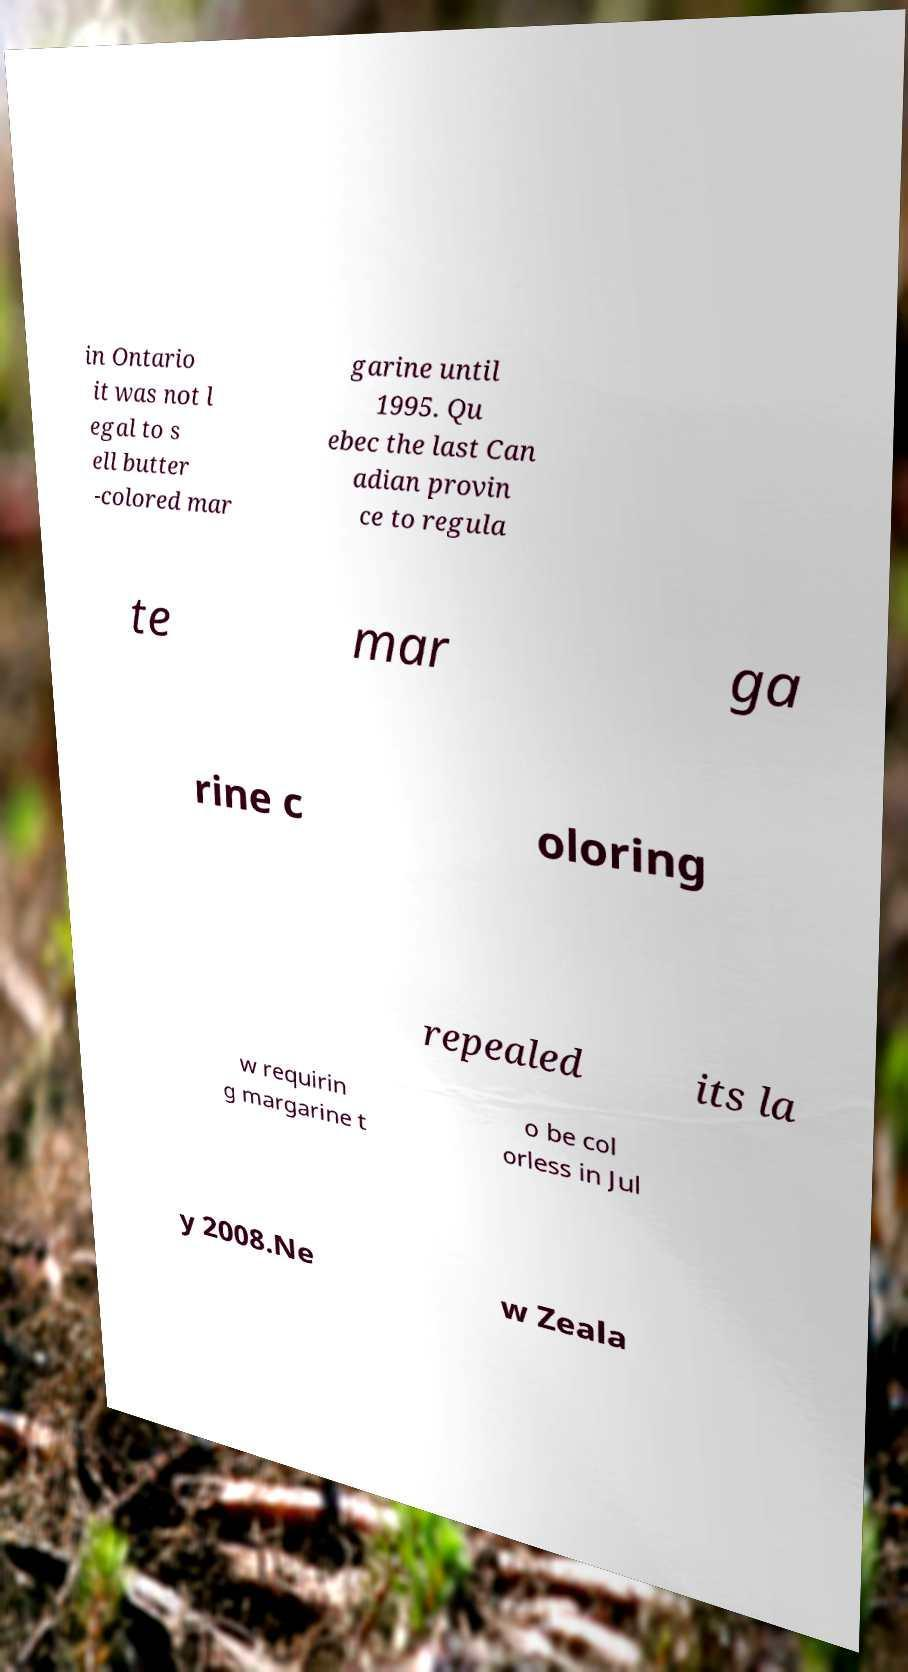I need the written content from this picture converted into text. Can you do that? in Ontario it was not l egal to s ell butter -colored mar garine until 1995. Qu ebec the last Can adian provin ce to regula te mar ga rine c oloring repealed its la w requirin g margarine t o be col orless in Jul y 2008.Ne w Zeala 